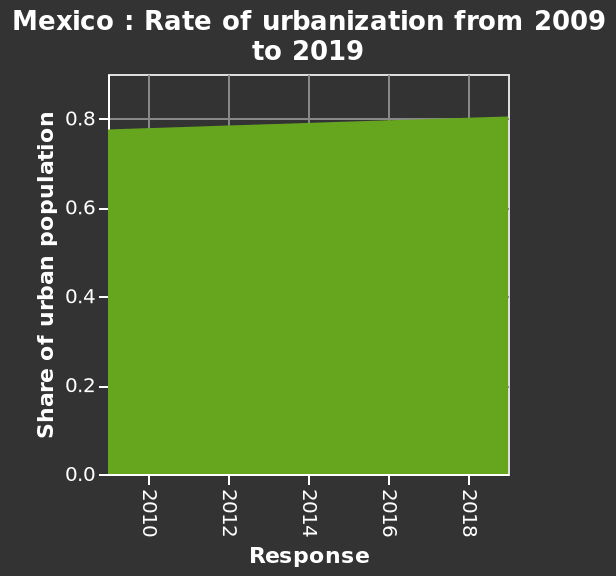<image>
What is the title of the area graph? The title of the area graph is "Mexico : Rate of urbanization from 2009 to 2019." What does the y-axis measure on the graph? The y-axis measures the share of urban population. How would you describe the rate of urbanisation? The rate of urbanisation has been slow over the 10-year period. What is the scale used on the x-axis? The scale used on the x-axis is linear. 